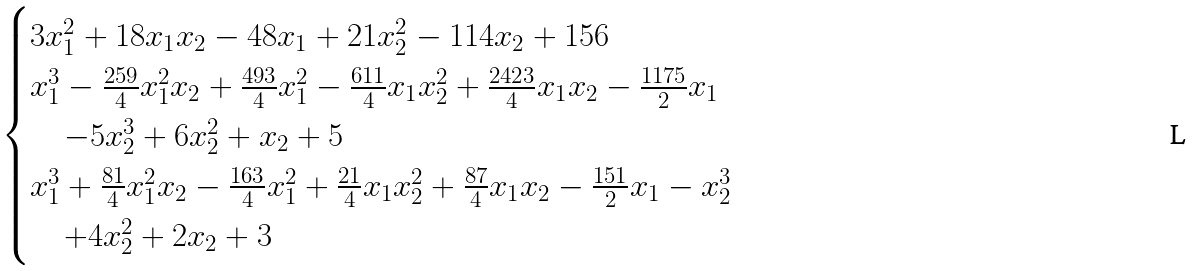<formula> <loc_0><loc_0><loc_500><loc_500>\begin{cases} 3 x _ { 1 } ^ { 2 } + 1 8 x _ { 1 } x _ { 2 } - 4 8 x _ { 1 } + 2 1 x _ { 2 } ^ { 2 } - 1 1 4 x _ { 2 } + 1 5 6 \\ x _ { 1 } ^ { 3 } - \frac { 2 5 9 } { 4 } x _ { 1 } ^ { 2 } x _ { 2 } + \frac { 4 9 3 } { 4 } x _ { 1 } ^ { 2 } - \frac { 6 1 1 } { 4 } x _ { 1 } x _ { 2 } ^ { 2 } + \frac { 2 4 2 3 } { 4 } x _ { 1 } x _ { 2 } - \frac { 1 1 7 5 } { 2 } x _ { 1 } \\ \quad - 5 x _ { 2 } ^ { 3 } + 6 x _ { 2 } ^ { 2 } + x _ { 2 } + 5 \\ x _ { 1 } ^ { 3 } + \frac { 8 1 } { 4 } x _ { 1 } ^ { 2 } x _ { 2 } - \frac { 1 6 3 } { 4 } x _ { 1 } ^ { 2 } + \frac { 2 1 } { 4 } x _ { 1 } x _ { 2 } ^ { 2 } + \frac { 8 7 } { 4 } x _ { 1 } x _ { 2 } - \frac { 1 5 1 } { 2 } x _ { 1 } - x _ { 2 } ^ { 3 } \\ \quad + 4 x _ { 2 } ^ { 2 } + 2 x _ { 2 } + 3 \end{cases}</formula> 